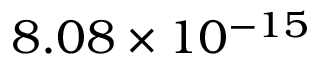<formula> <loc_0><loc_0><loc_500><loc_500>8 . 0 8 \times 1 0 ^ { - 1 5 }</formula> 